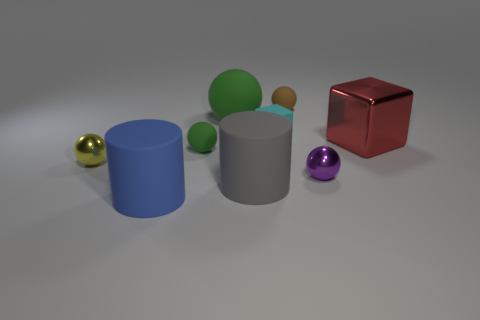Are there objects in the image that share both color and shape? No, each object in the image has its own distinct color and shape. The shapes include cylinders and spheres, while the colors present are blue, gray, green, red, gold, and purple. There's no repetition of the same color and shape combination within these objects. 